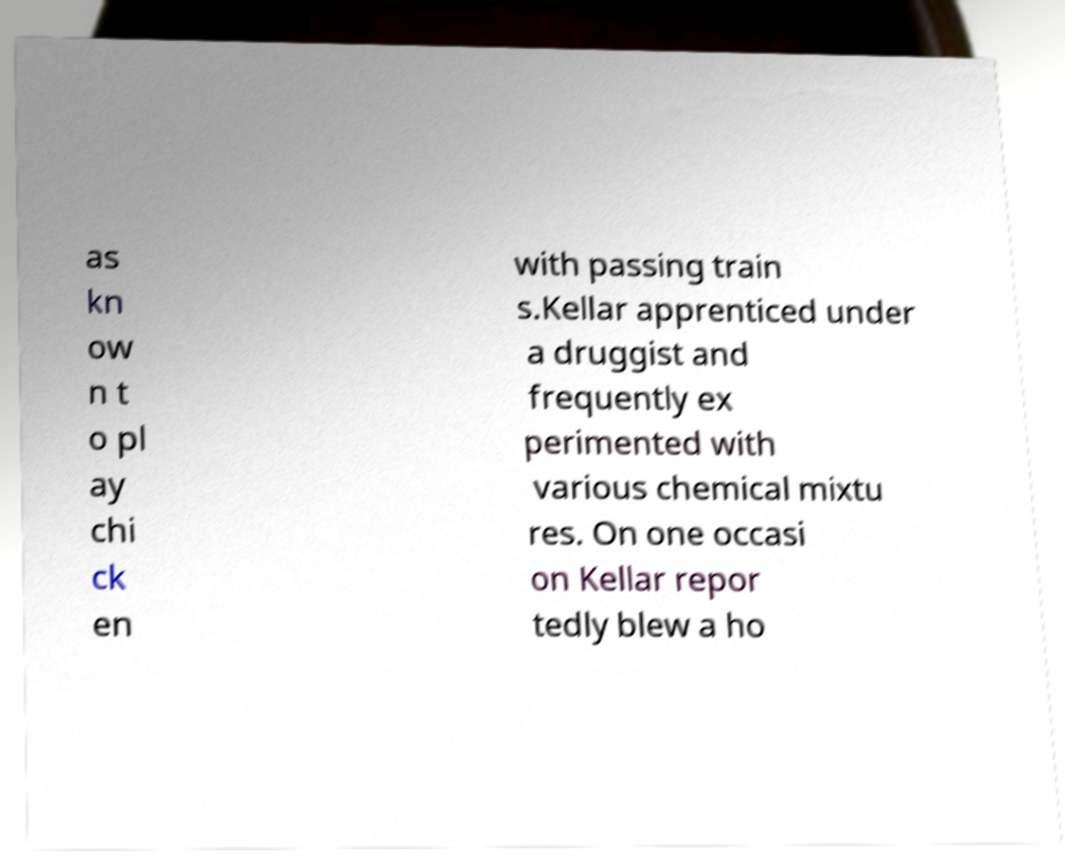There's text embedded in this image that I need extracted. Can you transcribe it verbatim? as kn ow n t o pl ay chi ck en with passing train s.Kellar apprenticed under a druggist and frequently ex perimented with various chemical mixtu res. On one occasi on Kellar repor tedly blew a ho 